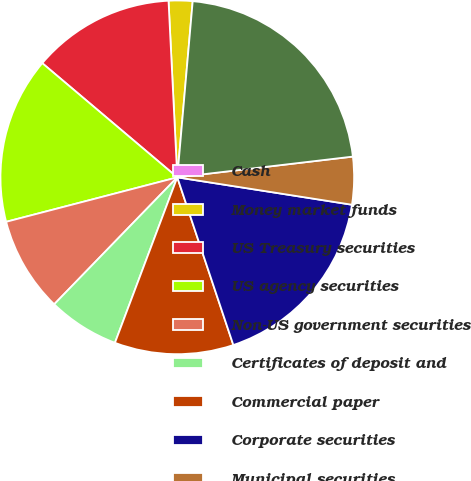Convert chart to OTSL. <chart><loc_0><loc_0><loc_500><loc_500><pie_chart><fcel>Cash<fcel>Money market funds<fcel>US Treasury securities<fcel>US agency securities<fcel>Non-US government securities<fcel>Certificates of deposit and<fcel>Commercial paper<fcel>Corporate securities<fcel>Municipal securities<fcel>Subtotal<nl><fcel>0.0%<fcel>2.18%<fcel>13.04%<fcel>15.22%<fcel>8.7%<fcel>6.52%<fcel>10.87%<fcel>17.39%<fcel>4.35%<fcel>21.74%<nl></chart> 